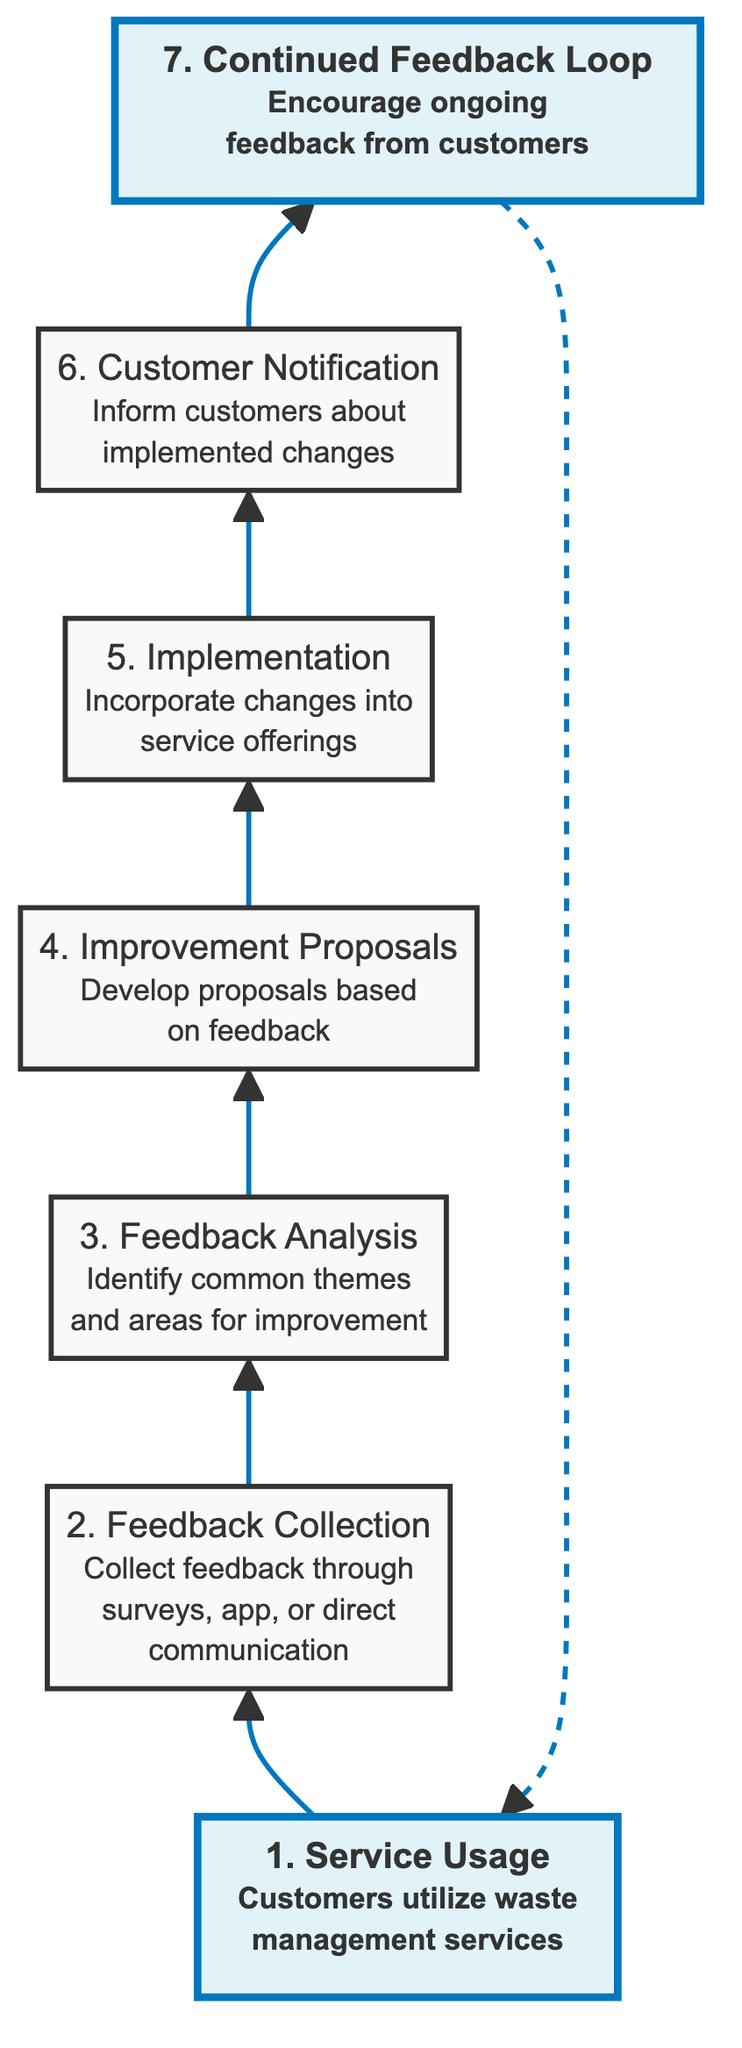What is the first step in the customer feedback flow? The first step in the flow is "Service Usage," where customers begin to utilize waste management services.
Answer: Service Usage How many steps are there in the customer feedback flow? The flow includes a total of 7 distinct steps, from service usage to the continued feedback loop.
Answer: 7 What step follows "Feedback Analysis"? The step that follows "Feedback Analysis" is "Improvement Proposals," where proposals are developed based on the feedback that was analyzed.
Answer: Improvement Proposals Which step includes informing customers about changes? The "Customer Notification" step is where customers are informed about the changes that have been implemented in service offerings.
Answer: Customer Notification What is the last step in the feedback flow? The last step in the feedback flow is "Continued Feedback Loop," which encourages ongoing feedback from customers.
Answer: Continued Feedback Loop What type of feedback collection methods are mentioned? The feedback is collected through methods such as surveys, mobile app, or direct communication after service completion.
Answer: Surveys, mobile app, or direct communication Which steps are highlighted in the diagram? The steps that are highlighted are "Service Usage" and "Continued Feedback Loop," indicating their importance in the feedback flow process.
Answer: Service Usage and Continued Feedback Loop What is the relationship between "Implementation of Improvements" and "Customer Notification"? The relationship is sequential; "Implementation of Improvements" comes before "Customer Notification," indicating that improvements are made before customers are notified of these changes.
Answer: Sequential relationship How does feedback flow back into the process after implementation? The flow back into the process is represented by the "Continued Feedback Loop," where customer feedback continues to be encouraged, allowing for future evaluations and modifications.
Answer: Through the Continued Feedback Loop 